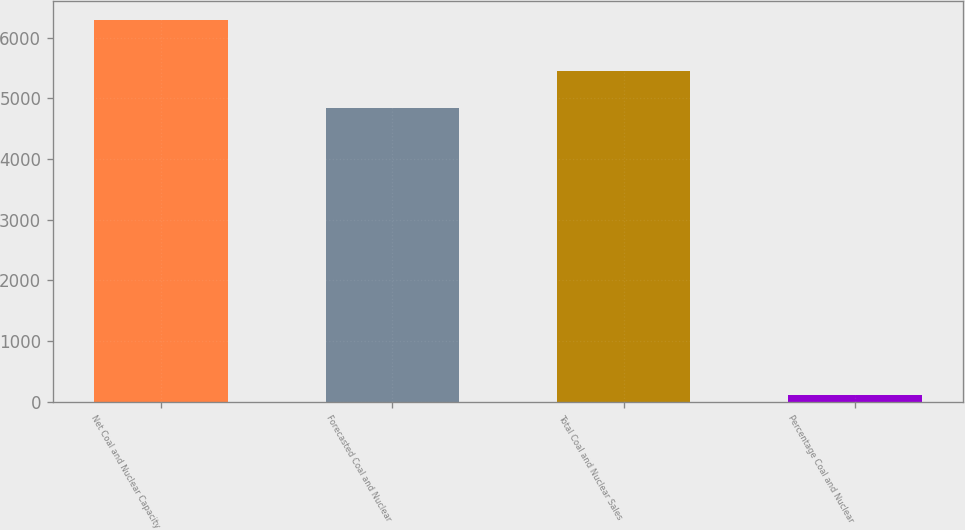Convert chart. <chart><loc_0><loc_0><loc_500><loc_500><bar_chart><fcel>Net Coal and Nuclear Capacity<fcel>Forecasted Coal and Nuclear<fcel>Total Coal and Nuclear Sales<fcel>Percentage Coal and Nuclear<nl><fcel>6290<fcel>4843<fcel>5461.5<fcel>105<nl></chart> 